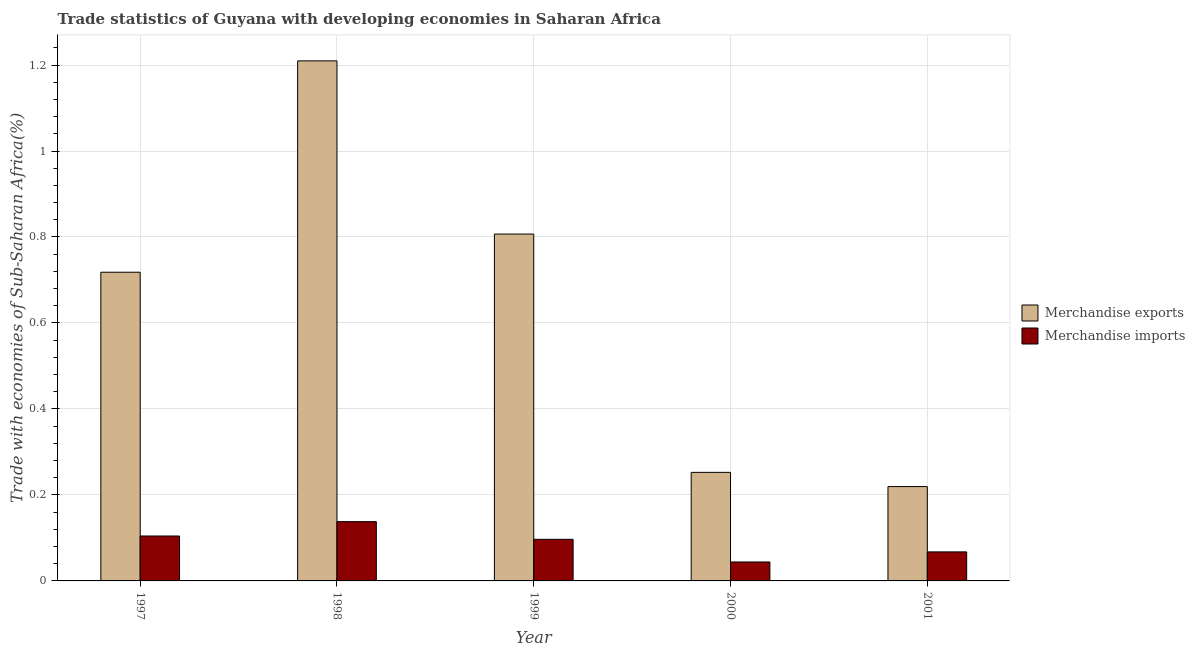How many groups of bars are there?
Provide a short and direct response. 5. Are the number of bars per tick equal to the number of legend labels?
Provide a short and direct response. Yes. Are the number of bars on each tick of the X-axis equal?
Provide a succinct answer. Yes. What is the label of the 5th group of bars from the left?
Make the answer very short. 2001. What is the merchandise imports in 2000?
Offer a terse response. 0.04. Across all years, what is the maximum merchandise imports?
Your response must be concise. 0.14. Across all years, what is the minimum merchandise imports?
Your answer should be very brief. 0.04. In which year was the merchandise imports maximum?
Make the answer very short. 1998. What is the total merchandise exports in the graph?
Your response must be concise. 3.21. What is the difference between the merchandise exports in 1997 and that in 2001?
Your response must be concise. 0.5. What is the difference between the merchandise exports in 1998 and the merchandise imports in 1999?
Make the answer very short. 0.4. What is the average merchandise imports per year?
Offer a very short reply. 0.09. What is the ratio of the merchandise imports in 1999 to that in 2000?
Offer a terse response. 2.2. What is the difference between the highest and the second highest merchandise exports?
Keep it short and to the point. 0.4. What is the difference between the highest and the lowest merchandise exports?
Offer a terse response. 0.99. Is the sum of the merchandise imports in 1999 and 2000 greater than the maximum merchandise exports across all years?
Your answer should be very brief. Yes. What does the 2nd bar from the right in 1997 represents?
Ensure brevity in your answer.  Merchandise exports. How many bars are there?
Ensure brevity in your answer.  10. Are the values on the major ticks of Y-axis written in scientific E-notation?
Make the answer very short. No. What is the title of the graph?
Give a very brief answer. Trade statistics of Guyana with developing economies in Saharan Africa. Does "Imports" appear as one of the legend labels in the graph?
Give a very brief answer. No. What is the label or title of the X-axis?
Provide a short and direct response. Year. What is the label or title of the Y-axis?
Keep it short and to the point. Trade with economies of Sub-Saharan Africa(%). What is the Trade with economies of Sub-Saharan Africa(%) in Merchandise exports in 1997?
Your answer should be compact. 0.72. What is the Trade with economies of Sub-Saharan Africa(%) of Merchandise imports in 1997?
Keep it short and to the point. 0.1. What is the Trade with economies of Sub-Saharan Africa(%) in Merchandise exports in 1998?
Your answer should be compact. 1.21. What is the Trade with economies of Sub-Saharan Africa(%) in Merchandise imports in 1998?
Make the answer very short. 0.14. What is the Trade with economies of Sub-Saharan Africa(%) of Merchandise exports in 1999?
Your answer should be compact. 0.81. What is the Trade with economies of Sub-Saharan Africa(%) in Merchandise imports in 1999?
Your answer should be very brief. 0.1. What is the Trade with economies of Sub-Saharan Africa(%) of Merchandise exports in 2000?
Give a very brief answer. 0.25. What is the Trade with economies of Sub-Saharan Africa(%) of Merchandise imports in 2000?
Provide a succinct answer. 0.04. What is the Trade with economies of Sub-Saharan Africa(%) in Merchandise exports in 2001?
Your answer should be very brief. 0.22. What is the Trade with economies of Sub-Saharan Africa(%) of Merchandise imports in 2001?
Your answer should be compact. 0.07. Across all years, what is the maximum Trade with economies of Sub-Saharan Africa(%) in Merchandise exports?
Offer a very short reply. 1.21. Across all years, what is the maximum Trade with economies of Sub-Saharan Africa(%) in Merchandise imports?
Offer a very short reply. 0.14. Across all years, what is the minimum Trade with economies of Sub-Saharan Africa(%) of Merchandise exports?
Offer a very short reply. 0.22. Across all years, what is the minimum Trade with economies of Sub-Saharan Africa(%) in Merchandise imports?
Your response must be concise. 0.04. What is the total Trade with economies of Sub-Saharan Africa(%) in Merchandise exports in the graph?
Your answer should be compact. 3.21. What is the total Trade with economies of Sub-Saharan Africa(%) in Merchandise imports in the graph?
Give a very brief answer. 0.45. What is the difference between the Trade with economies of Sub-Saharan Africa(%) in Merchandise exports in 1997 and that in 1998?
Ensure brevity in your answer.  -0.49. What is the difference between the Trade with economies of Sub-Saharan Africa(%) in Merchandise imports in 1997 and that in 1998?
Provide a succinct answer. -0.03. What is the difference between the Trade with economies of Sub-Saharan Africa(%) of Merchandise exports in 1997 and that in 1999?
Your answer should be very brief. -0.09. What is the difference between the Trade with economies of Sub-Saharan Africa(%) of Merchandise imports in 1997 and that in 1999?
Provide a succinct answer. 0.01. What is the difference between the Trade with economies of Sub-Saharan Africa(%) in Merchandise exports in 1997 and that in 2000?
Offer a very short reply. 0.47. What is the difference between the Trade with economies of Sub-Saharan Africa(%) of Merchandise imports in 1997 and that in 2000?
Give a very brief answer. 0.06. What is the difference between the Trade with economies of Sub-Saharan Africa(%) in Merchandise exports in 1997 and that in 2001?
Ensure brevity in your answer.  0.5. What is the difference between the Trade with economies of Sub-Saharan Africa(%) in Merchandise imports in 1997 and that in 2001?
Your answer should be compact. 0.04. What is the difference between the Trade with economies of Sub-Saharan Africa(%) in Merchandise exports in 1998 and that in 1999?
Provide a short and direct response. 0.4. What is the difference between the Trade with economies of Sub-Saharan Africa(%) in Merchandise imports in 1998 and that in 1999?
Provide a short and direct response. 0.04. What is the difference between the Trade with economies of Sub-Saharan Africa(%) in Merchandise exports in 1998 and that in 2000?
Your answer should be compact. 0.96. What is the difference between the Trade with economies of Sub-Saharan Africa(%) of Merchandise imports in 1998 and that in 2000?
Make the answer very short. 0.09. What is the difference between the Trade with economies of Sub-Saharan Africa(%) in Merchandise exports in 1998 and that in 2001?
Your response must be concise. 0.99. What is the difference between the Trade with economies of Sub-Saharan Africa(%) in Merchandise imports in 1998 and that in 2001?
Your answer should be very brief. 0.07. What is the difference between the Trade with economies of Sub-Saharan Africa(%) in Merchandise exports in 1999 and that in 2000?
Make the answer very short. 0.55. What is the difference between the Trade with economies of Sub-Saharan Africa(%) of Merchandise imports in 1999 and that in 2000?
Your answer should be very brief. 0.05. What is the difference between the Trade with economies of Sub-Saharan Africa(%) of Merchandise exports in 1999 and that in 2001?
Keep it short and to the point. 0.59. What is the difference between the Trade with economies of Sub-Saharan Africa(%) in Merchandise imports in 1999 and that in 2001?
Give a very brief answer. 0.03. What is the difference between the Trade with economies of Sub-Saharan Africa(%) in Merchandise exports in 2000 and that in 2001?
Your answer should be very brief. 0.03. What is the difference between the Trade with economies of Sub-Saharan Africa(%) in Merchandise imports in 2000 and that in 2001?
Keep it short and to the point. -0.02. What is the difference between the Trade with economies of Sub-Saharan Africa(%) in Merchandise exports in 1997 and the Trade with economies of Sub-Saharan Africa(%) in Merchandise imports in 1998?
Provide a succinct answer. 0.58. What is the difference between the Trade with economies of Sub-Saharan Africa(%) of Merchandise exports in 1997 and the Trade with economies of Sub-Saharan Africa(%) of Merchandise imports in 1999?
Give a very brief answer. 0.62. What is the difference between the Trade with economies of Sub-Saharan Africa(%) of Merchandise exports in 1997 and the Trade with economies of Sub-Saharan Africa(%) of Merchandise imports in 2000?
Provide a short and direct response. 0.67. What is the difference between the Trade with economies of Sub-Saharan Africa(%) in Merchandise exports in 1997 and the Trade with economies of Sub-Saharan Africa(%) in Merchandise imports in 2001?
Keep it short and to the point. 0.65. What is the difference between the Trade with economies of Sub-Saharan Africa(%) in Merchandise exports in 1998 and the Trade with economies of Sub-Saharan Africa(%) in Merchandise imports in 1999?
Offer a very short reply. 1.11. What is the difference between the Trade with economies of Sub-Saharan Africa(%) in Merchandise exports in 1998 and the Trade with economies of Sub-Saharan Africa(%) in Merchandise imports in 2000?
Ensure brevity in your answer.  1.17. What is the difference between the Trade with economies of Sub-Saharan Africa(%) in Merchandise exports in 1998 and the Trade with economies of Sub-Saharan Africa(%) in Merchandise imports in 2001?
Your answer should be compact. 1.14. What is the difference between the Trade with economies of Sub-Saharan Africa(%) in Merchandise exports in 1999 and the Trade with economies of Sub-Saharan Africa(%) in Merchandise imports in 2000?
Your response must be concise. 0.76. What is the difference between the Trade with economies of Sub-Saharan Africa(%) in Merchandise exports in 1999 and the Trade with economies of Sub-Saharan Africa(%) in Merchandise imports in 2001?
Your response must be concise. 0.74. What is the difference between the Trade with economies of Sub-Saharan Africa(%) in Merchandise exports in 2000 and the Trade with economies of Sub-Saharan Africa(%) in Merchandise imports in 2001?
Keep it short and to the point. 0.18. What is the average Trade with economies of Sub-Saharan Africa(%) in Merchandise exports per year?
Your answer should be compact. 0.64. What is the average Trade with economies of Sub-Saharan Africa(%) of Merchandise imports per year?
Give a very brief answer. 0.09. In the year 1997, what is the difference between the Trade with economies of Sub-Saharan Africa(%) of Merchandise exports and Trade with economies of Sub-Saharan Africa(%) of Merchandise imports?
Provide a succinct answer. 0.61. In the year 1998, what is the difference between the Trade with economies of Sub-Saharan Africa(%) of Merchandise exports and Trade with economies of Sub-Saharan Africa(%) of Merchandise imports?
Keep it short and to the point. 1.07. In the year 1999, what is the difference between the Trade with economies of Sub-Saharan Africa(%) in Merchandise exports and Trade with economies of Sub-Saharan Africa(%) in Merchandise imports?
Provide a short and direct response. 0.71. In the year 2000, what is the difference between the Trade with economies of Sub-Saharan Africa(%) in Merchandise exports and Trade with economies of Sub-Saharan Africa(%) in Merchandise imports?
Your answer should be very brief. 0.21. In the year 2001, what is the difference between the Trade with economies of Sub-Saharan Africa(%) in Merchandise exports and Trade with economies of Sub-Saharan Africa(%) in Merchandise imports?
Ensure brevity in your answer.  0.15. What is the ratio of the Trade with economies of Sub-Saharan Africa(%) of Merchandise exports in 1997 to that in 1998?
Offer a very short reply. 0.59. What is the ratio of the Trade with economies of Sub-Saharan Africa(%) in Merchandise imports in 1997 to that in 1998?
Provide a short and direct response. 0.76. What is the ratio of the Trade with economies of Sub-Saharan Africa(%) of Merchandise exports in 1997 to that in 1999?
Give a very brief answer. 0.89. What is the ratio of the Trade with economies of Sub-Saharan Africa(%) of Merchandise imports in 1997 to that in 1999?
Offer a terse response. 1.08. What is the ratio of the Trade with economies of Sub-Saharan Africa(%) in Merchandise exports in 1997 to that in 2000?
Your response must be concise. 2.84. What is the ratio of the Trade with economies of Sub-Saharan Africa(%) in Merchandise imports in 1997 to that in 2000?
Your answer should be compact. 2.37. What is the ratio of the Trade with economies of Sub-Saharan Africa(%) in Merchandise exports in 1997 to that in 2001?
Your response must be concise. 3.27. What is the ratio of the Trade with economies of Sub-Saharan Africa(%) in Merchandise imports in 1997 to that in 2001?
Your answer should be very brief. 1.55. What is the ratio of the Trade with economies of Sub-Saharan Africa(%) of Merchandise exports in 1998 to that in 1999?
Give a very brief answer. 1.5. What is the ratio of the Trade with economies of Sub-Saharan Africa(%) in Merchandise imports in 1998 to that in 1999?
Give a very brief answer. 1.43. What is the ratio of the Trade with economies of Sub-Saharan Africa(%) of Merchandise exports in 1998 to that in 2000?
Provide a succinct answer. 4.79. What is the ratio of the Trade with economies of Sub-Saharan Africa(%) in Merchandise imports in 1998 to that in 2000?
Your answer should be very brief. 3.13. What is the ratio of the Trade with economies of Sub-Saharan Africa(%) in Merchandise exports in 1998 to that in 2001?
Provide a short and direct response. 5.51. What is the ratio of the Trade with economies of Sub-Saharan Africa(%) of Merchandise imports in 1998 to that in 2001?
Your answer should be very brief. 2.04. What is the ratio of the Trade with economies of Sub-Saharan Africa(%) in Merchandise exports in 1999 to that in 2000?
Your response must be concise. 3.2. What is the ratio of the Trade with economies of Sub-Saharan Africa(%) in Merchandise imports in 1999 to that in 2000?
Ensure brevity in your answer.  2.2. What is the ratio of the Trade with economies of Sub-Saharan Africa(%) in Merchandise exports in 1999 to that in 2001?
Provide a short and direct response. 3.68. What is the ratio of the Trade with economies of Sub-Saharan Africa(%) in Merchandise imports in 1999 to that in 2001?
Your answer should be compact. 1.43. What is the ratio of the Trade with economies of Sub-Saharan Africa(%) in Merchandise exports in 2000 to that in 2001?
Keep it short and to the point. 1.15. What is the ratio of the Trade with economies of Sub-Saharan Africa(%) of Merchandise imports in 2000 to that in 2001?
Offer a very short reply. 0.65. What is the difference between the highest and the second highest Trade with economies of Sub-Saharan Africa(%) of Merchandise exports?
Make the answer very short. 0.4. What is the difference between the highest and the second highest Trade with economies of Sub-Saharan Africa(%) in Merchandise imports?
Keep it short and to the point. 0.03. What is the difference between the highest and the lowest Trade with economies of Sub-Saharan Africa(%) in Merchandise exports?
Give a very brief answer. 0.99. What is the difference between the highest and the lowest Trade with economies of Sub-Saharan Africa(%) of Merchandise imports?
Offer a terse response. 0.09. 